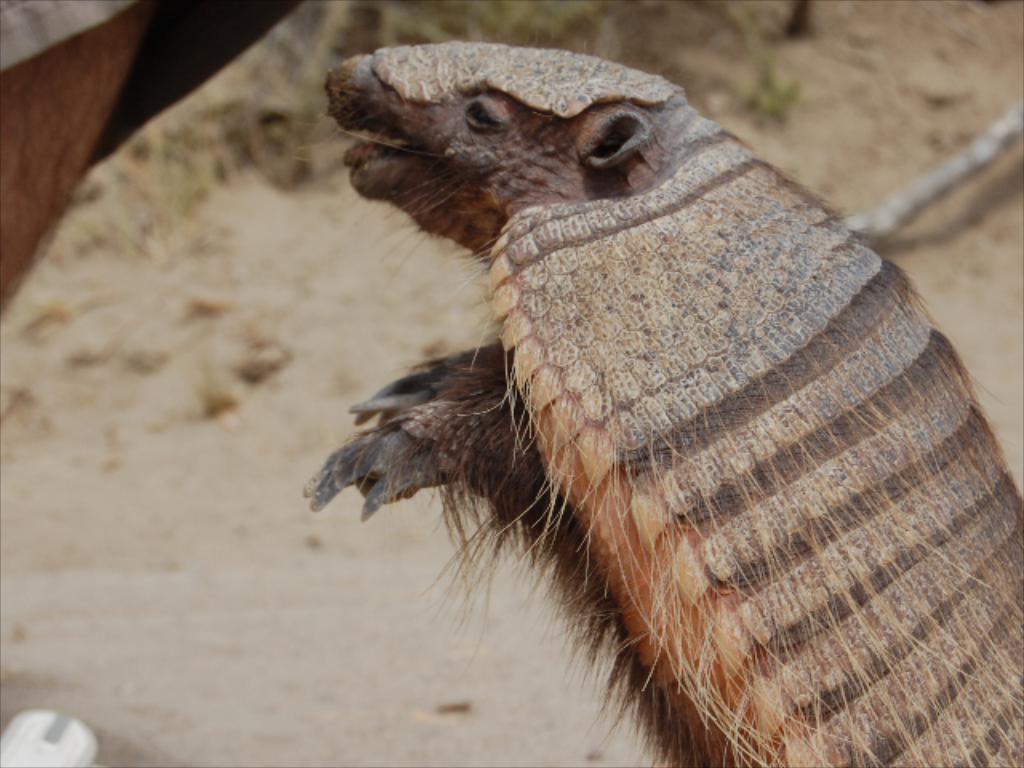Please provide a concise description of this image. In this image I can see an animal which is in cream and brown color. To the left I can see the person. In the background I can see the ground. On the ground I can see the grass and the stick. 